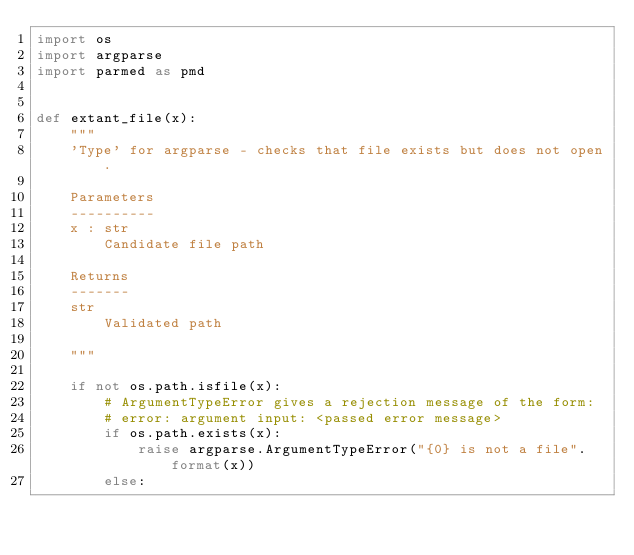<code> <loc_0><loc_0><loc_500><loc_500><_Python_>import os
import argparse
import parmed as pmd


def extant_file(x):
    """
    'Type' for argparse - checks that file exists but does not open.

    Parameters
    ----------
    x : str
        Candidate file path

    Returns
    -------
    str
        Validated path

    """

    if not os.path.isfile(x):
        # ArgumentTypeError gives a rejection message of the form:
        # error: argument input: <passed error message>
        if os.path.exists(x):
            raise argparse.ArgumentTypeError("{0} is not a file".format(x))
        else:</code> 